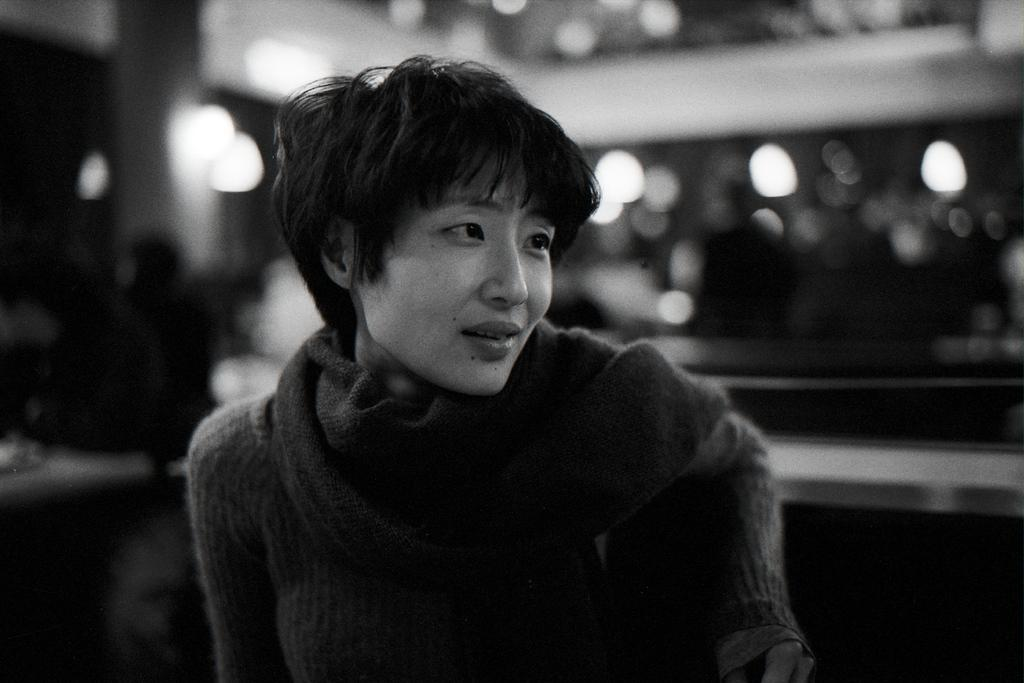What is the color scheme of the image? The image is black and white. Who is present in the image? There is a woman in the image. Can you describe the background of the image? The background of the image is blurred, and there is a wall visible. What else can be seen in the background? There are lights and people (few persons) visible in the background, as well as other unspecified objects. What type of ring is the woman wearing in the image? There is no ring visible on the woman in the image. Can you describe the collar of the woman's pet in the image? There is no pet or collar present in the image. 